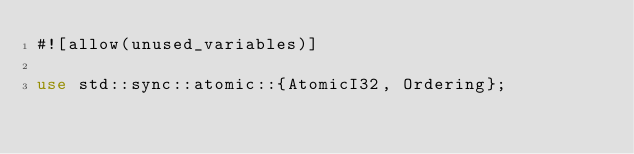<code> <loc_0><loc_0><loc_500><loc_500><_Rust_>#![allow(unused_variables)]

use std::sync::atomic::{AtomicI32, Ordering};</code> 